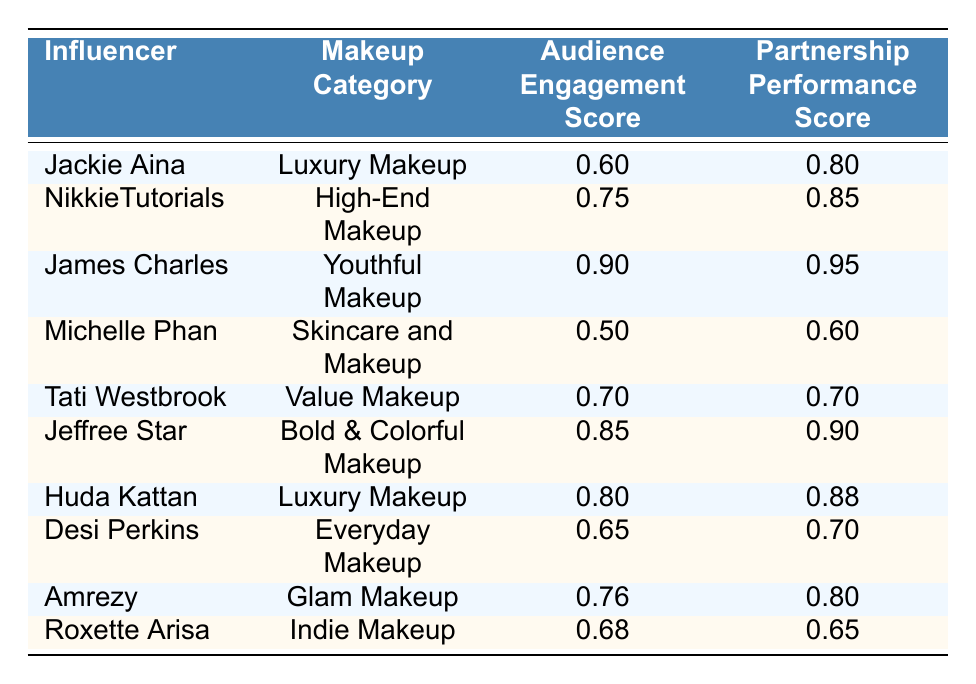What is the Audience Engagement Score for Jeffree Star? Jeffree Star has an Audience Engagement Score listed in the table, which is 0.85.
Answer: 0.85 What is the Partnership Performance Score for Michelle Phan? From the table, Michelle Phan's Partnership Performance Score is indicated as 0.60.
Answer: 0.60 Which influencer has the highest Audience Engagement Score? By examining the Audience Engagement Scores in the table, James Charles has the highest score of 0.90.
Answer: James Charles What is the average Audience Engagement Score for Luxury Makeup? The Audience Engagement Scores for Luxury Makeup influencers Jackie Aina (0.60) and Huda Kattan (0.80) are combined: (0.60 + 0.80) / 2 = 0.70.
Answer: 0.70 Is it true that Tati Westbrook has a higher Partnership Performance Score than Desi Perkins? Tati Westbrook's Partnership Performance Score is 0.70, while Desi Perkins' is 0.70. Since they are equal, the statement is false.
Answer: No What is the difference between the highest and lowest Partnership Performance Scores? The highest Partnership Performance Score is 0.95 (James Charles), and the lowest is 0.60 (Michelle Phan). The difference is 0.95 - 0.60 = 0.35.
Answer: 0.35 How many influencers have Audience Engagement Scores above 0.75? The influencers with scores above 0.75 are NikkieTutorials (0.75), James Charles (0.90), Jeffree Star (0.85), and Huda Kattan (0.80), which sums up to a total of four influencers.
Answer: 4 Which makeup category has the lowest average Partnership Performance Score? The average Partnership Performance Scores for each category are calculated: Luxury Makeup (0.84), High-End Makeup (0.85), Youthful Makeup (0.95), Skincare and Makeup (0.60), Value Makeup (0.70), Bold & Colorful Makeup (0.90), Everyday Makeup (0.70), Glam Makeup (0.80), and Indie Makeup (0.65). The lowest average score is found in Skincare and Makeup with an average of 0.60.
Answer: Skincare and Makeup Is Huda Kattan's Audience Engagement Score greater than 0.75? Huda Kattan's Audience Engagement Score in the table is 0.80, which is greater than 0.75, confirming the statement is true.
Answer: Yes 